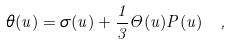<formula> <loc_0><loc_0><loc_500><loc_500>\theta ( u ) = \sigma ( u ) + \frac { 1 } { 3 } \Theta ( u ) P ( u ) \ ,</formula> 